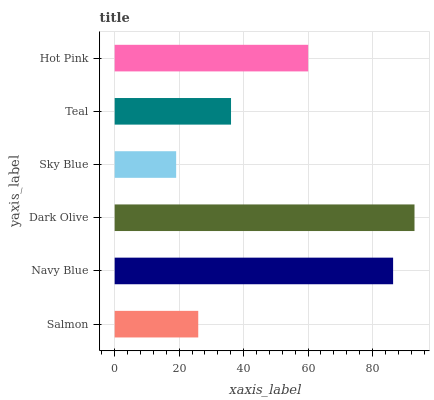Is Sky Blue the minimum?
Answer yes or no. Yes. Is Dark Olive the maximum?
Answer yes or no. Yes. Is Navy Blue the minimum?
Answer yes or no. No. Is Navy Blue the maximum?
Answer yes or no. No. Is Navy Blue greater than Salmon?
Answer yes or no. Yes. Is Salmon less than Navy Blue?
Answer yes or no. Yes. Is Salmon greater than Navy Blue?
Answer yes or no. No. Is Navy Blue less than Salmon?
Answer yes or no. No. Is Hot Pink the high median?
Answer yes or no. Yes. Is Teal the low median?
Answer yes or no. Yes. Is Navy Blue the high median?
Answer yes or no. No. Is Salmon the low median?
Answer yes or no. No. 